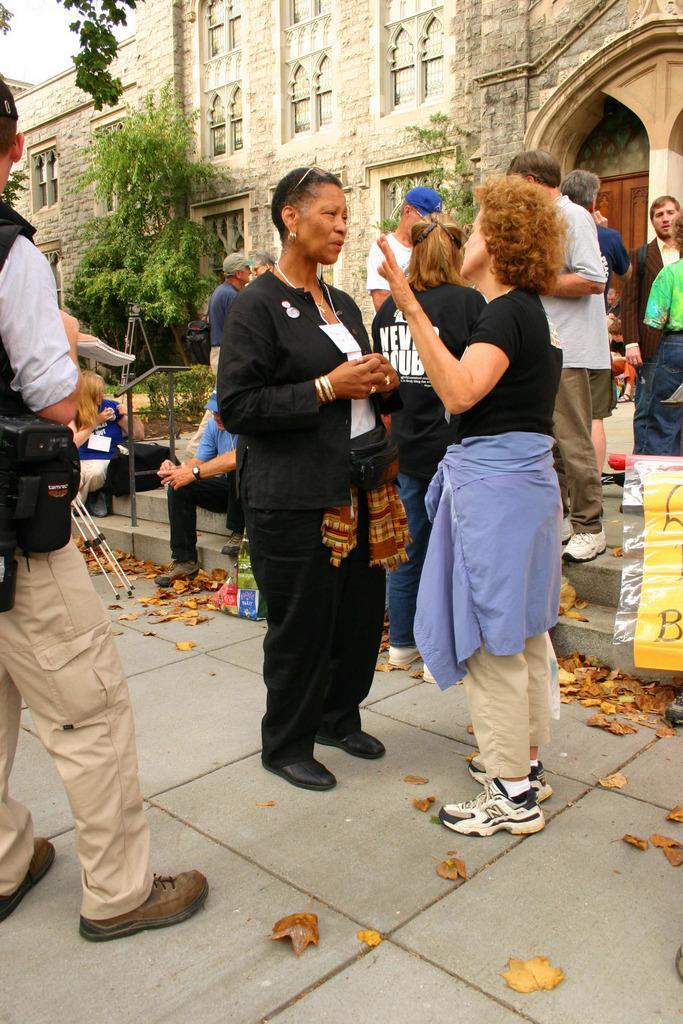In one or two sentences, can you explain what this image depicts? In this picture we can see some people are in one place, behind we can see building and trees, we can see dry leaves on the floor. 